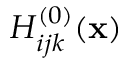<formula> <loc_0><loc_0><loc_500><loc_500>H _ { i j k } ^ { ( 0 ) } ( { x } )</formula> 